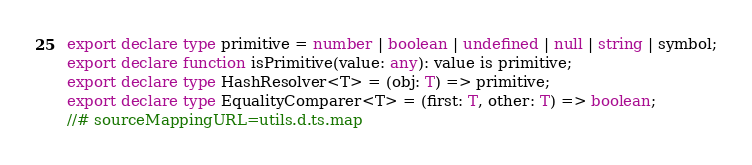<code> <loc_0><loc_0><loc_500><loc_500><_TypeScript_>export declare type primitive = number | boolean | undefined | null | string | symbol;
export declare function isPrimitive(value: any): value is primitive;
export declare type HashResolver<T> = (obj: T) => primitive;
export declare type EqualityComparer<T> = (first: T, other: T) => boolean;
//# sourceMappingURL=utils.d.ts.map</code> 